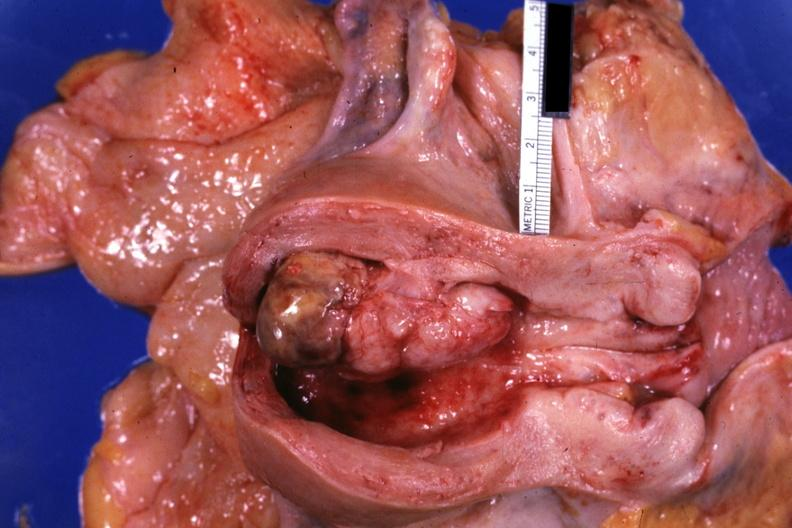what opened uterus shows tumor?
Answer the question using a single word or phrase. This 